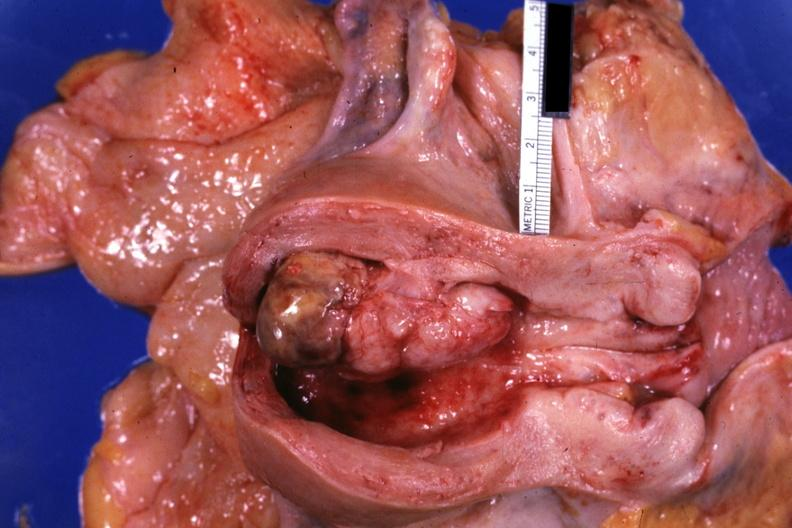what opened uterus shows tumor?
Answer the question using a single word or phrase. This 